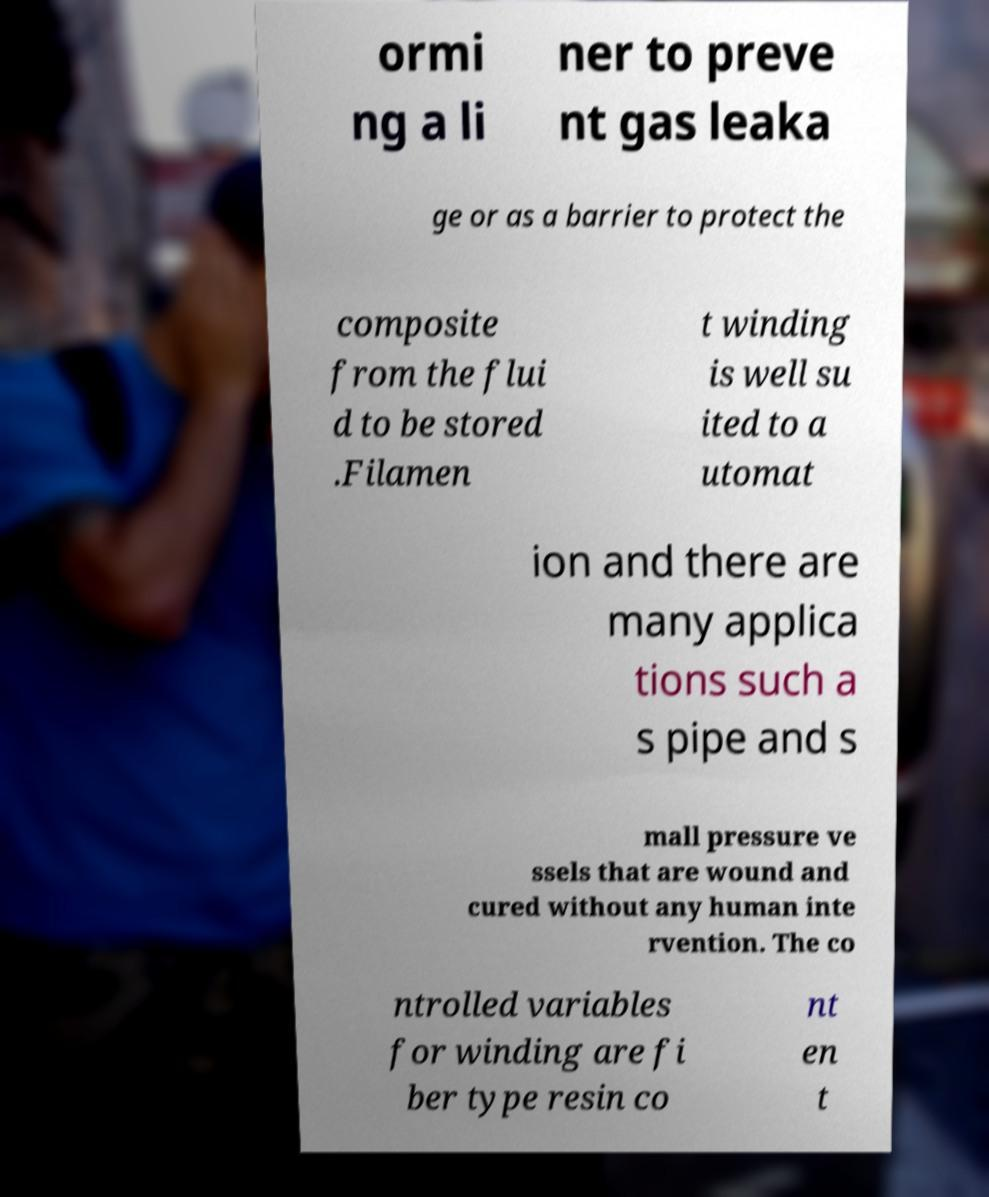Can you accurately transcribe the text from the provided image for me? ormi ng a li ner to preve nt gas leaka ge or as a barrier to protect the composite from the flui d to be stored .Filamen t winding is well su ited to a utomat ion and there are many applica tions such a s pipe and s mall pressure ve ssels that are wound and cured without any human inte rvention. The co ntrolled variables for winding are fi ber type resin co nt en t 